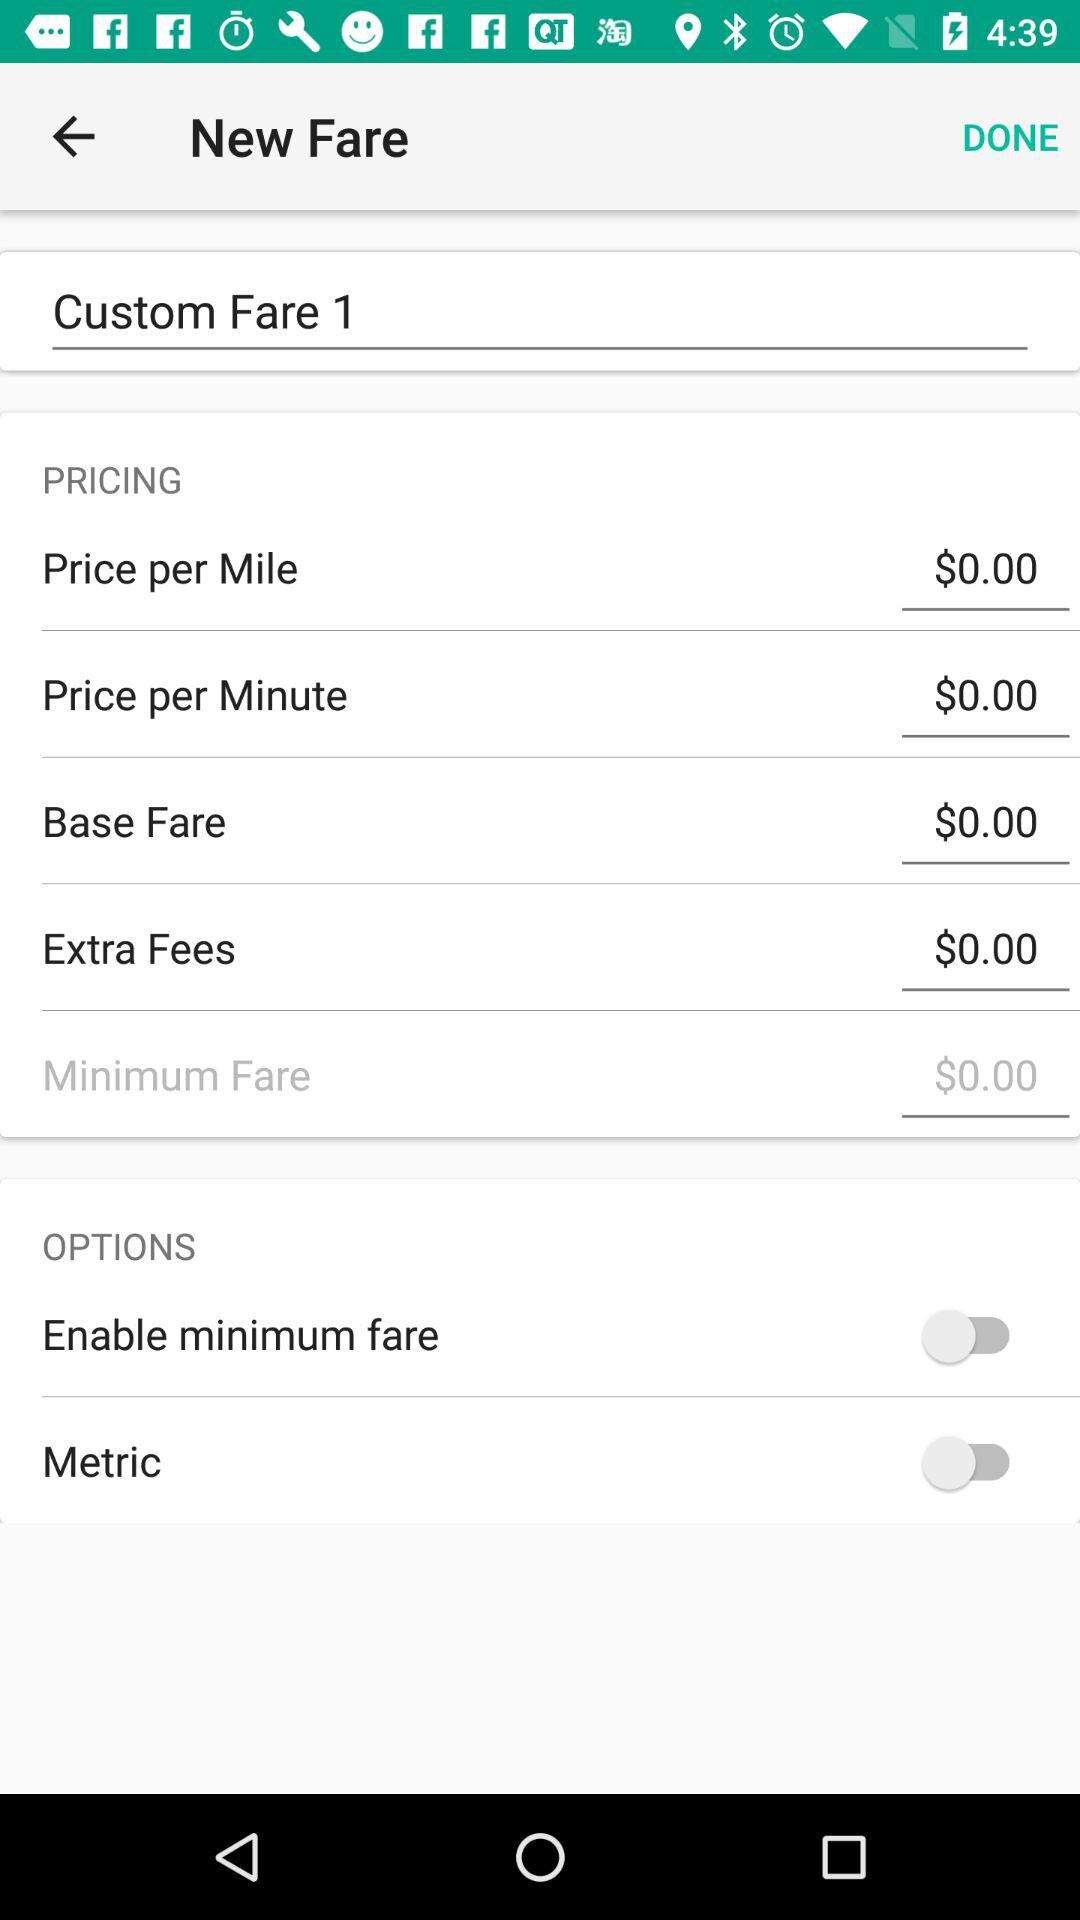How much is the total cost?
When the provided information is insufficient, respond with <no answer>. <no answer> 